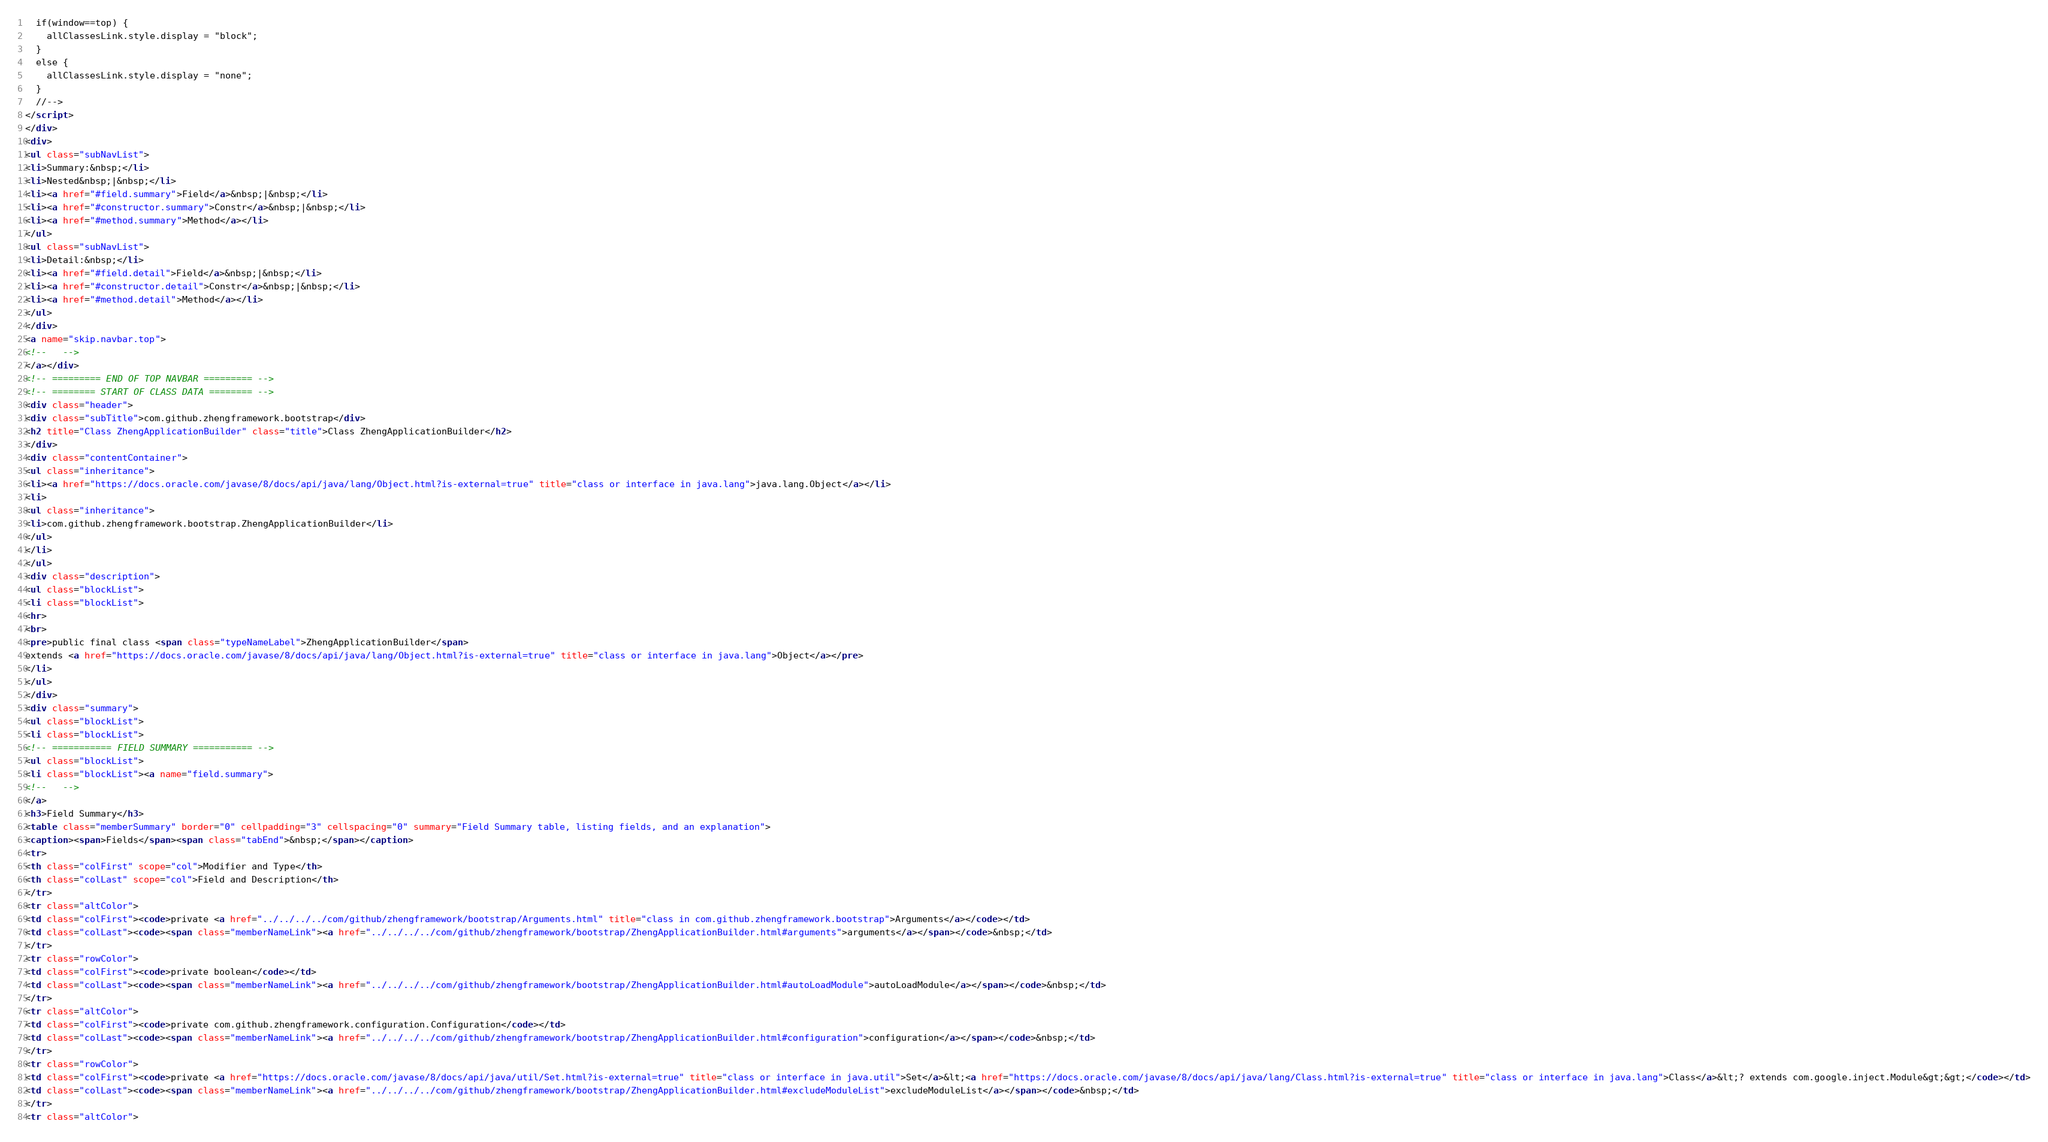Convert code to text. <code><loc_0><loc_0><loc_500><loc_500><_HTML_>  if(window==top) {
    allClassesLink.style.display = "block";
  }
  else {
    allClassesLink.style.display = "none";
  }
  //-->
</script>
</div>
<div>
<ul class="subNavList">
<li>Summary:&nbsp;</li>
<li>Nested&nbsp;|&nbsp;</li>
<li><a href="#field.summary">Field</a>&nbsp;|&nbsp;</li>
<li><a href="#constructor.summary">Constr</a>&nbsp;|&nbsp;</li>
<li><a href="#method.summary">Method</a></li>
</ul>
<ul class="subNavList">
<li>Detail:&nbsp;</li>
<li><a href="#field.detail">Field</a>&nbsp;|&nbsp;</li>
<li><a href="#constructor.detail">Constr</a>&nbsp;|&nbsp;</li>
<li><a href="#method.detail">Method</a></li>
</ul>
</div>
<a name="skip.navbar.top">
<!--   -->
</a></div>
<!-- ========= END OF TOP NAVBAR ========= -->
<!-- ======== START OF CLASS DATA ======== -->
<div class="header">
<div class="subTitle">com.github.zhengframework.bootstrap</div>
<h2 title="Class ZhengApplicationBuilder" class="title">Class ZhengApplicationBuilder</h2>
</div>
<div class="contentContainer">
<ul class="inheritance">
<li><a href="https://docs.oracle.com/javase/8/docs/api/java/lang/Object.html?is-external=true" title="class or interface in java.lang">java.lang.Object</a></li>
<li>
<ul class="inheritance">
<li>com.github.zhengframework.bootstrap.ZhengApplicationBuilder</li>
</ul>
</li>
</ul>
<div class="description">
<ul class="blockList">
<li class="blockList">
<hr>
<br>
<pre>public final class <span class="typeNameLabel">ZhengApplicationBuilder</span>
extends <a href="https://docs.oracle.com/javase/8/docs/api/java/lang/Object.html?is-external=true" title="class or interface in java.lang">Object</a></pre>
</li>
</ul>
</div>
<div class="summary">
<ul class="blockList">
<li class="blockList">
<!-- =========== FIELD SUMMARY =========== -->
<ul class="blockList">
<li class="blockList"><a name="field.summary">
<!--   -->
</a>
<h3>Field Summary</h3>
<table class="memberSummary" border="0" cellpadding="3" cellspacing="0" summary="Field Summary table, listing fields, and an explanation">
<caption><span>Fields</span><span class="tabEnd">&nbsp;</span></caption>
<tr>
<th class="colFirst" scope="col">Modifier and Type</th>
<th class="colLast" scope="col">Field and Description</th>
</tr>
<tr class="altColor">
<td class="colFirst"><code>private <a href="../../../../com/github/zhengframework/bootstrap/Arguments.html" title="class in com.github.zhengframework.bootstrap">Arguments</a></code></td>
<td class="colLast"><code><span class="memberNameLink"><a href="../../../../com/github/zhengframework/bootstrap/ZhengApplicationBuilder.html#arguments">arguments</a></span></code>&nbsp;</td>
</tr>
<tr class="rowColor">
<td class="colFirst"><code>private boolean</code></td>
<td class="colLast"><code><span class="memberNameLink"><a href="../../../../com/github/zhengframework/bootstrap/ZhengApplicationBuilder.html#autoLoadModule">autoLoadModule</a></span></code>&nbsp;</td>
</tr>
<tr class="altColor">
<td class="colFirst"><code>private com.github.zhengframework.configuration.Configuration</code></td>
<td class="colLast"><code><span class="memberNameLink"><a href="../../../../com/github/zhengframework/bootstrap/ZhengApplicationBuilder.html#configuration">configuration</a></span></code>&nbsp;</td>
</tr>
<tr class="rowColor">
<td class="colFirst"><code>private <a href="https://docs.oracle.com/javase/8/docs/api/java/util/Set.html?is-external=true" title="class or interface in java.util">Set</a>&lt;<a href="https://docs.oracle.com/javase/8/docs/api/java/lang/Class.html?is-external=true" title="class or interface in java.lang">Class</a>&lt;? extends com.google.inject.Module&gt;&gt;</code></td>
<td class="colLast"><code><span class="memberNameLink"><a href="../../../../com/github/zhengframework/bootstrap/ZhengApplicationBuilder.html#excludeModuleList">excludeModuleList</a></span></code>&nbsp;</td>
</tr>
<tr class="altColor"></code> 